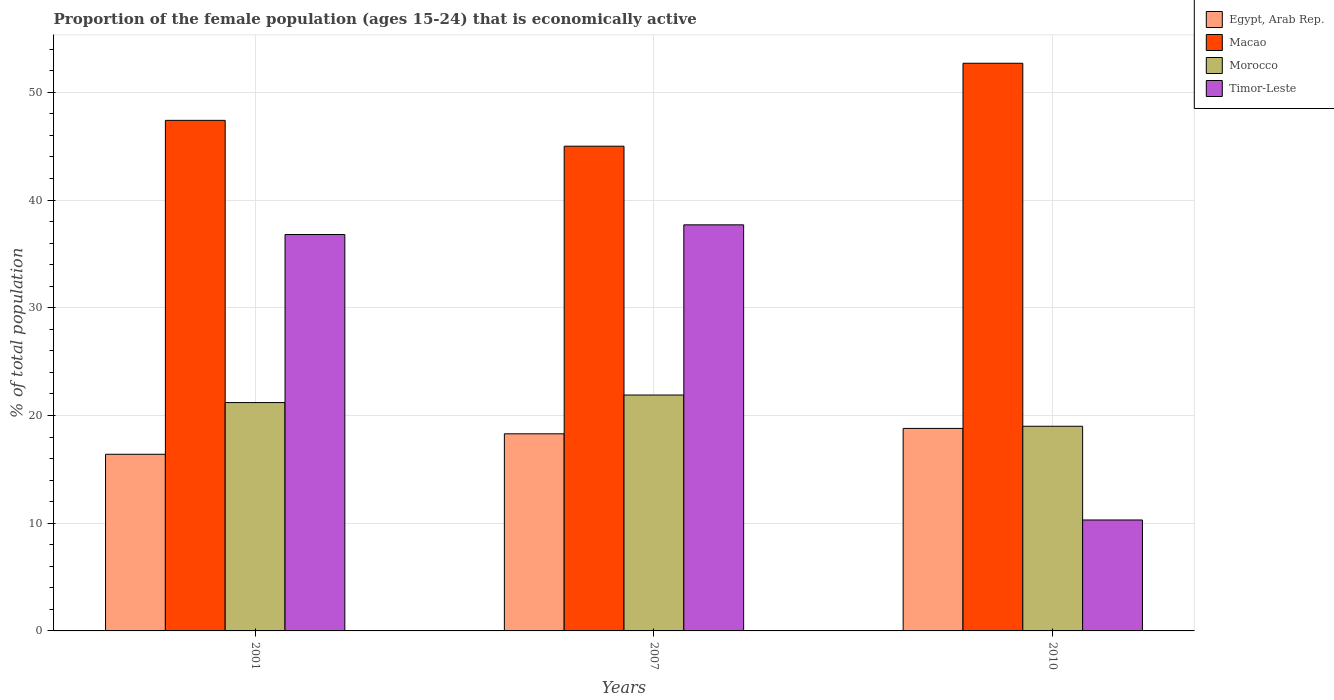How many groups of bars are there?
Ensure brevity in your answer.  3. Are the number of bars per tick equal to the number of legend labels?
Your answer should be compact. Yes. How many bars are there on the 1st tick from the left?
Provide a succinct answer. 4. How many bars are there on the 1st tick from the right?
Provide a succinct answer. 4. In how many cases, is the number of bars for a given year not equal to the number of legend labels?
Ensure brevity in your answer.  0. What is the proportion of the female population that is economically active in Macao in 2001?
Keep it short and to the point. 47.4. Across all years, what is the maximum proportion of the female population that is economically active in Morocco?
Provide a short and direct response. 21.9. Across all years, what is the minimum proportion of the female population that is economically active in Egypt, Arab Rep.?
Your answer should be very brief. 16.4. In which year was the proportion of the female population that is economically active in Morocco maximum?
Give a very brief answer. 2007. In which year was the proportion of the female population that is economically active in Egypt, Arab Rep. minimum?
Your answer should be very brief. 2001. What is the total proportion of the female population that is economically active in Timor-Leste in the graph?
Offer a terse response. 84.8. What is the difference between the proportion of the female population that is economically active in Morocco in 2007 and that in 2010?
Provide a short and direct response. 2.9. What is the difference between the proportion of the female population that is economically active in Timor-Leste in 2010 and the proportion of the female population that is economically active in Macao in 2001?
Offer a terse response. -37.1. What is the average proportion of the female population that is economically active in Egypt, Arab Rep. per year?
Offer a terse response. 17.83. In the year 2007, what is the difference between the proportion of the female population that is economically active in Macao and proportion of the female population that is economically active in Egypt, Arab Rep.?
Offer a terse response. 26.7. In how many years, is the proportion of the female population that is economically active in Egypt, Arab Rep. greater than 20 %?
Provide a short and direct response. 0. What is the ratio of the proportion of the female population that is economically active in Egypt, Arab Rep. in 2001 to that in 2007?
Ensure brevity in your answer.  0.9. Is the proportion of the female population that is economically active in Egypt, Arab Rep. in 2001 less than that in 2007?
Offer a very short reply. Yes. What is the difference between the highest and the second highest proportion of the female population that is economically active in Macao?
Your answer should be compact. 5.3. What is the difference between the highest and the lowest proportion of the female population that is economically active in Morocco?
Your answer should be very brief. 2.9. Is the sum of the proportion of the female population that is economically active in Morocco in 2001 and 2010 greater than the maximum proportion of the female population that is economically active in Macao across all years?
Provide a short and direct response. No. Is it the case that in every year, the sum of the proportion of the female population that is economically active in Timor-Leste and proportion of the female population that is economically active in Morocco is greater than the sum of proportion of the female population that is economically active in Egypt, Arab Rep. and proportion of the female population that is economically active in Macao?
Provide a short and direct response. No. What does the 1st bar from the left in 2001 represents?
Provide a succinct answer. Egypt, Arab Rep. What does the 4th bar from the right in 2007 represents?
Provide a short and direct response. Egypt, Arab Rep. How many years are there in the graph?
Offer a very short reply. 3. What is the difference between two consecutive major ticks on the Y-axis?
Provide a succinct answer. 10. Are the values on the major ticks of Y-axis written in scientific E-notation?
Give a very brief answer. No. Does the graph contain any zero values?
Ensure brevity in your answer.  No. Where does the legend appear in the graph?
Ensure brevity in your answer.  Top right. How are the legend labels stacked?
Keep it short and to the point. Vertical. What is the title of the graph?
Your answer should be very brief. Proportion of the female population (ages 15-24) that is economically active. Does "Equatorial Guinea" appear as one of the legend labels in the graph?
Offer a terse response. No. What is the label or title of the X-axis?
Give a very brief answer. Years. What is the label or title of the Y-axis?
Make the answer very short. % of total population. What is the % of total population of Egypt, Arab Rep. in 2001?
Offer a terse response. 16.4. What is the % of total population in Macao in 2001?
Provide a succinct answer. 47.4. What is the % of total population of Morocco in 2001?
Provide a succinct answer. 21.2. What is the % of total population of Timor-Leste in 2001?
Offer a terse response. 36.8. What is the % of total population of Egypt, Arab Rep. in 2007?
Ensure brevity in your answer.  18.3. What is the % of total population in Macao in 2007?
Offer a terse response. 45. What is the % of total population in Morocco in 2007?
Provide a succinct answer. 21.9. What is the % of total population in Timor-Leste in 2007?
Your answer should be very brief. 37.7. What is the % of total population in Egypt, Arab Rep. in 2010?
Provide a short and direct response. 18.8. What is the % of total population in Macao in 2010?
Provide a succinct answer. 52.7. What is the % of total population in Morocco in 2010?
Your answer should be compact. 19. What is the % of total population in Timor-Leste in 2010?
Offer a very short reply. 10.3. Across all years, what is the maximum % of total population in Egypt, Arab Rep.?
Offer a very short reply. 18.8. Across all years, what is the maximum % of total population of Macao?
Give a very brief answer. 52.7. Across all years, what is the maximum % of total population of Morocco?
Your answer should be very brief. 21.9. Across all years, what is the maximum % of total population in Timor-Leste?
Offer a terse response. 37.7. Across all years, what is the minimum % of total population of Egypt, Arab Rep.?
Your answer should be compact. 16.4. Across all years, what is the minimum % of total population of Timor-Leste?
Your response must be concise. 10.3. What is the total % of total population of Egypt, Arab Rep. in the graph?
Provide a short and direct response. 53.5. What is the total % of total population in Macao in the graph?
Provide a short and direct response. 145.1. What is the total % of total population of Morocco in the graph?
Provide a succinct answer. 62.1. What is the total % of total population of Timor-Leste in the graph?
Your answer should be very brief. 84.8. What is the difference between the % of total population in Egypt, Arab Rep. in 2001 and that in 2007?
Your answer should be compact. -1.9. What is the difference between the % of total population of Egypt, Arab Rep. in 2001 and that in 2010?
Make the answer very short. -2.4. What is the difference between the % of total population of Macao in 2001 and that in 2010?
Make the answer very short. -5.3. What is the difference between the % of total population of Egypt, Arab Rep. in 2007 and that in 2010?
Ensure brevity in your answer.  -0.5. What is the difference between the % of total population of Macao in 2007 and that in 2010?
Your answer should be compact. -7.7. What is the difference between the % of total population of Morocco in 2007 and that in 2010?
Make the answer very short. 2.9. What is the difference between the % of total population in Timor-Leste in 2007 and that in 2010?
Provide a succinct answer. 27.4. What is the difference between the % of total population of Egypt, Arab Rep. in 2001 and the % of total population of Macao in 2007?
Offer a terse response. -28.6. What is the difference between the % of total population of Egypt, Arab Rep. in 2001 and the % of total population of Morocco in 2007?
Make the answer very short. -5.5. What is the difference between the % of total population in Egypt, Arab Rep. in 2001 and the % of total population in Timor-Leste in 2007?
Give a very brief answer. -21.3. What is the difference between the % of total population of Macao in 2001 and the % of total population of Timor-Leste in 2007?
Keep it short and to the point. 9.7. What is the difference between the % of total population in Morocco in 2001 and the % of total population in Timor-Leste in 2007?
Your answer should be compact. -16.5. What is the difference between the % of total population in Egypt, Arab Rep. in 2001 and the % of total population in Macao in 2010?
Your answer should be very brief. -36.3. What is the difference between the % of total population of Egypt, Arab Rep. in 2001 and the % of total population of Timor-Leste in 2010?
Offer a very short reply. 6.1. What is the difference between the % of total population of Macao in 2001 and the % of total population of Morocco in 2010?
Offer a terse response. 28.4. What is the difference between the % of total population of Macao in 2001 and the % of total population of Timor-Leste in 2010?
Keep it short and to the point. 37.1. What is the difference between the % of total population of Egypt, Arab Rep. in 2007 and the % of total population of Macao in 2010?
Provide a short and direct response. -34.4. What is the difference between the % of total population in Egypt, Arab Rep. in 2007 and the % of total population in Timor-Leste in 2010?
Your answer should be compact. 8. What is the difference between the % of total population in Macao in 2007 and the % of total population in Timor-Leste in 2010?
Offer a terse response. 34.7. What is the average % of total population in Egypt, Arab Rep. per year?
Provide a short and direct response. 17.83. What is the average % of total population in Macao per year?
Make the answer very short. 48.37. What is the average % of total population in Morocco per year?
Offer a very short reply. 20.7. What is the average % of total population of Timor-Leste per year?
Offer a very short reply. 28.27. In the year 2001, what is the difference between the % of total population in Egypt, Arab Rep. and % of total population in Macao?
Your response must be concise. -31. In the year 2001, what is the difference between the % of total population in Egypt, Arab Rep. and % of total population in Timor-Leste?
Give a very brief answer. -20.4. In the year 2001, what is the difference between the % of total population in Macao and % of total population in Morocco?
Give a very brief answer. 26.2. In the year 2001, what is the difference between the % of total population of Macao and % of total population of Timor-Leste?
Provide a short and direct response. 10.6. In the year 2001, what is the difference between the % of total population of Morocco and % of total population of Timor-Leste?
Your response must be concise. -15.6. In the year 2007, what is the difference between the % of total population of Egypt, Arab Rep. and % of total population of Macao?
Give a very brief answer. -26.7. In the year 2007, what is the difference between the % of total population in Egypt, Arab Rep. and % of total population in Morocco?
Provide a short and direct response. -3.6. In the year 2007, what is the difference between the % of total population in Egypt, Arab Rep. and % of total population in Timor-Leste?
Ensure brevity in your answer.  -19.4. In the year 2007, what is the difference between the % of total population in Macao and % of total population in Morocco?
Give a very brief answer. 23.1. In the year 2007, what is the difference between the % of total population in Morocco and % of total population in Timor-Leste?
Keep it short and to the point. -15.8. In the year 2010, what is the difference between the % of total population of Egypt, Arab Rep. and % of total population of Macao?
Ensure brevity in your answer.  -33.9. In the year 2010, what is the difference between the % of total population in Egypt, Arab Rep. and % of total population in Morocco?
Provide a succinct answer. -0.2. In the year 2010, what is the difference between the % of total population in Egypt, Arab Rep. and % of total population in Timor-Leste?
Give a very brief answer. 8.5. In the year 2010, what is the difference between the % of total population of Macao and % of total population of Morocco?
Give a very brief answer. 33.7. In the year 2010, what is the difference between the % of total population in Macao and % of total population in Timor-Leste?
Give a very brief answer. 42.4. What is the ratio of the % of total population in Egypt, Arab Rep. in 2001 to that in 2007?
Your answer should be very brief. 0.9. What is the ratio of the % of total population of Macao in 2001 to that in 2007?
Offer a very short reply. 1.05. What is the ratio of the % of total population in Morocco in 2001 to that in 2007?
Ensure brevity in your answer.  0.97. What is the ratio of the % of total population in Timor-Leste in 2001 to that in 2007?
Your answer should be compact. 0.98. What is the ratio of the % of total population of Egypt, Arab Rep. in 2001 to that in 2010?
Your response must be concise. 0.87. What is the ratio of the % of total population in Macao in 2001 to that in 2010?
Offer a terse response. 0.9. What is the ratio of the % of total population of Morocco in 2001 to that in 2010?
Give a very brief answer. 1.12. What is the ratio of the % of total population of Timor-Leste in 2001 to that in 2010?
Make the answer very short. 3.57. What is the ratio of the % of total population of Egypt, Arab Rep. in 2007 to that in 2010?
Provide a succinct answer. 0.97. What is the ratio of the % of total population in Macao in 2007 to that in 2010?
Offer a terse response. 0.85. What is the ratio of the % of total population in Morocco in 2007 to that in 2010?
Your answer should be compact. 1.15. What is the ratio of the % of total population of Timor-Leste in 2007 to that in 2010?
Offer a very short reply. 3.66. What is the difference between the highest and the second highest % of total population of Egypt, Arab Rep.?
Ensure brevity in your answer.  0.5. What is the difference between the highest and the lowest % of total population in Egypt, Arab Rep.?
Provide a short and direct response. 2.4. What is the difference between the highest and the lowest % of total population in Morocco?
Make the answer very short. 2.9. What is the difference between the highest and the lowest % of total population in Timor-Leste?
Provide a short and direct response. 27.4. 